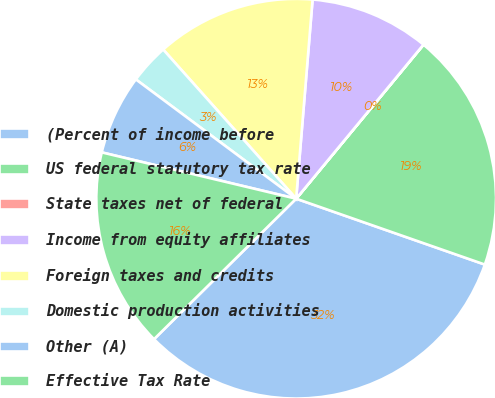Convert chart. <chart><loc_0><loc_0><loc_500><loc_500><pie_chart><fcel>(Percent of income before<fcel>US federal statutory tax rate<fcel>State taxes net of federal<fcel>Income from equity affiliates<fcel>Foreign taxes and credits<fcel>Domestic production activities<fcel>Other (A)<fcel>Effective Tax Rate<nl><fcel>32.25%<fcel>19.35%<fcel>0.01%<fcel>9.68%<fcel>12.9%<fcel>3.23%<fcel>6.46%<fcel>16.13%<nl></chart> 